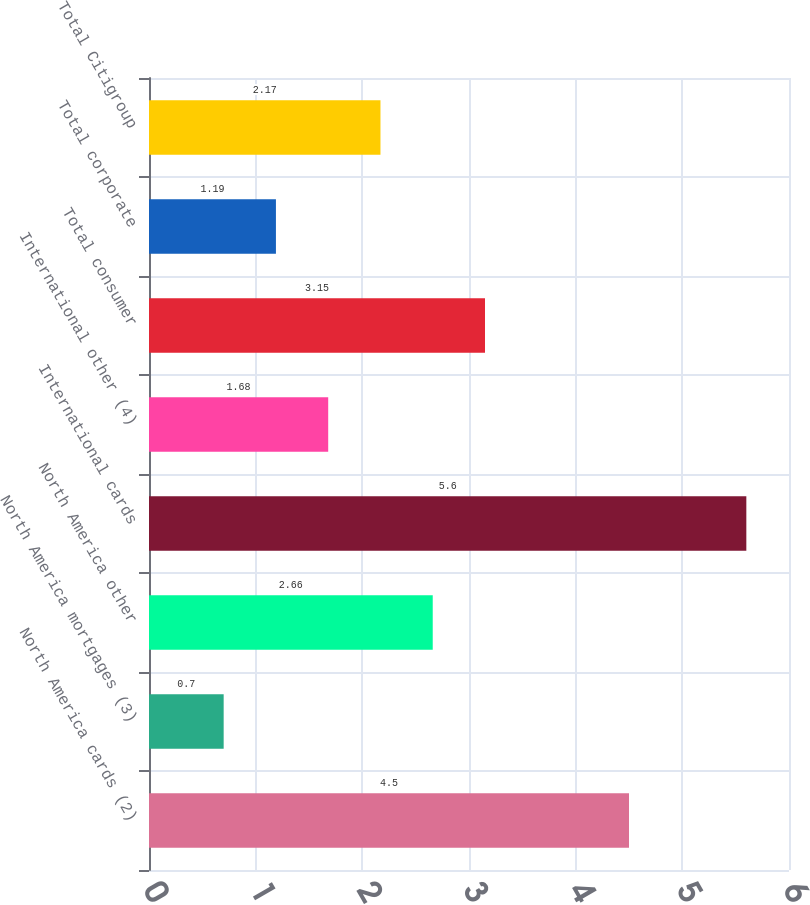Convert chart to OTSL. <chart><loc_0><loc_0><loc_500><loc_500><bar_chart><fcel>North America cards (2)<fcel>North America mortgages (3)<fcel>North America other<fcel>International cards<fcel>International other (4)<fcel>Total consumer<fcel>Total corporate<fcel>Total Citigroup<nl><fcel>4.5<fcel>0.7<fcel>2.66<fcel>5.6<fcel>1.68<fcel>3.15<fcel>1.19<fcel>2.17<nl></chart> 